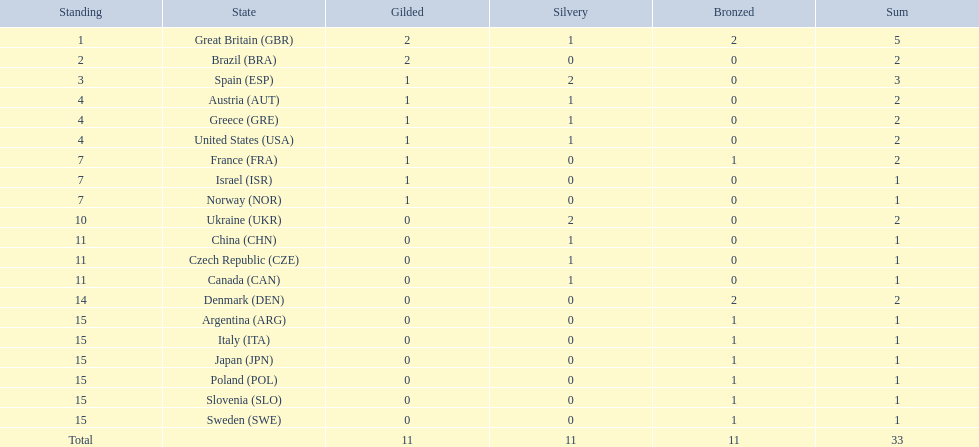What nation was beside great britain in total medal ranking? Spain. 